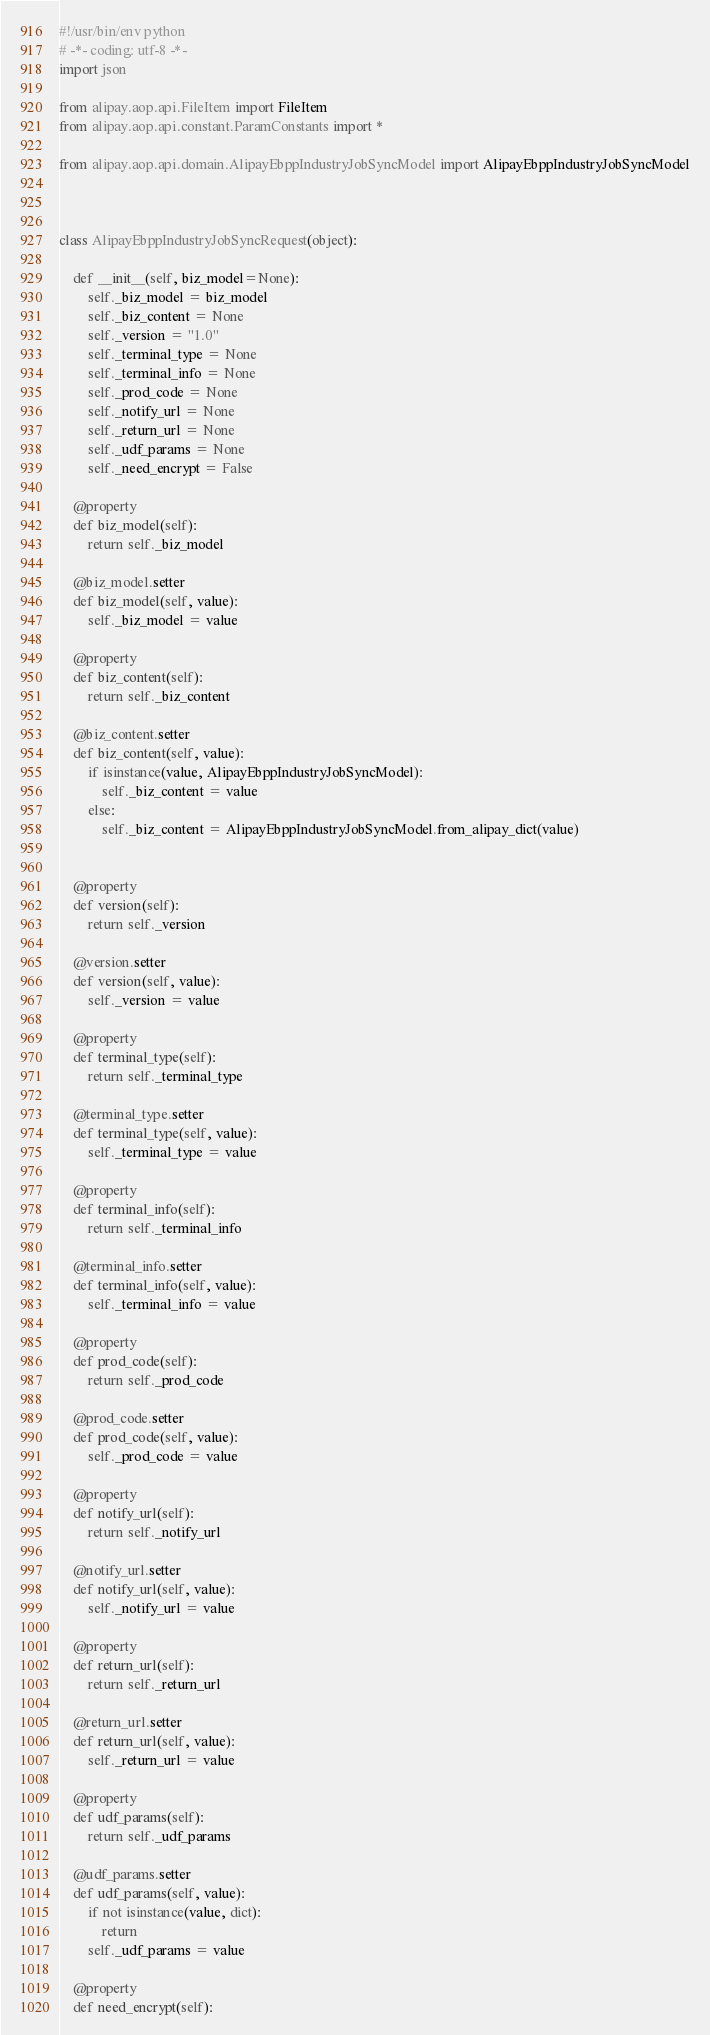<code> <loc_0><loc_0><loc_500><loc_500><_Python_>#!/usr/bin/env python
# -*- coding: utf-8 -*-
import json

from alipay.aop.api.FileItem import FileItem
from alipay.aop.api.constant.ParamConstants import *

from alipay.aop.api.domain.AlipayEbppIndustryJobSyncModel import AlipayEbppIndustryJobSyncModel



class AlipayEbppIndustryJobSyncRequest(object):

    def __init__(self, biz_model=None):
        self._biz_model = biz_model
        self._biz_content = None
        self._version = "1.0"
        self._terminal_type = None
        self._terminal_info = None
        self._prod_code = None
        self._notify_url = None
        self._return_url = None
        self._udf_params = None
        self._need_encrypt = False

    @property
    def biz_model(self):
        return self._biz_model

    @biz_model.setter
    def biz_model(self, value):
        self._biz_model = value

    @property
    def biz_content(self):
        return self._biz_content

    @biz_content.setter
    def biz_content(self, value):
        if isinstance(value, AlipayEbppIndustryJobSyncModel):
            self._biz_content = value
        else:
            self._biz_content = AlipayEbppIndustryJobSyncModel.from_alipay_dict(value)


    @property
    def version(self):
        return self._version

    @version.setter
    def version(self, value):
        self._version = value

    @property
    def terminal_type(self):
        return self._terminal_type

    @terminal_type.setter
    def terminal_type(self, value):
        self._terminal_type = value

    @property
    def terminal_info(self):
        return self._terminal_info

    @terminal_info.setter
    def terminal_info(self, value):
        self._terminal_info = value

    @property
    def prod_code(self):
        return self._prod_code

    @prod_code.setter
    def prod_code(self, value):
        self._prod_code = value

    @property
    def notify_url(self):
        return self._notify_url

    @notify_url.setter
    def notify_url(self, value):
        self._notify_url = value

    @property
    def return_url(self):
        return self._return_url

    @return_url.setter
    def return_url(self, value):
        self._return_url = value

    @property
    def udf_params(self):
        return self._udf_params

    @udf_params.setter
    def udf_params(self, value):
        if not isinstance(value, dict):
            return
        self._udf_params = value

    @property
    def need_encrypt(self):</code> 